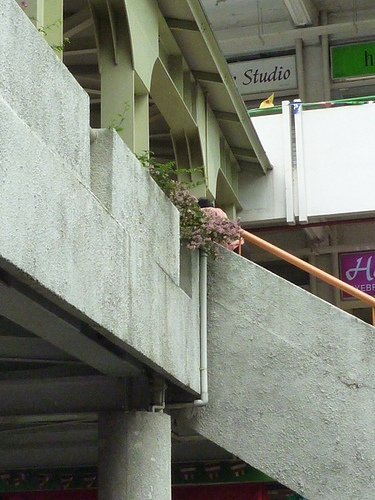<image>
Can you confirm if the flowers is on the building? Yes. Looking at the image, I can see the flowers is positioned on top of the building, with the building providing support. 